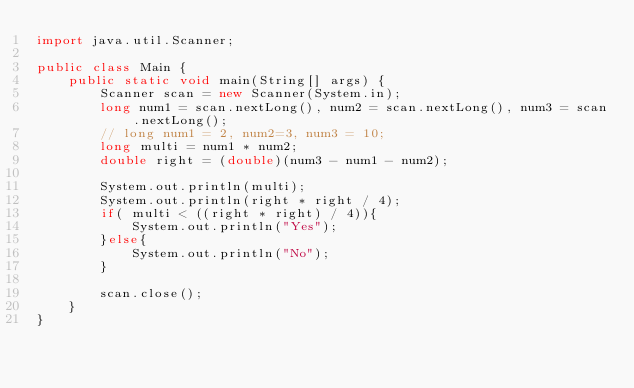Convert code to text. <code><loc_0><loc_0><loc_500><loc_500><_Java_>import java.util.Scanner;
 
public class Main {
    public static void main(String[] args) {
        Scanner scan = new Scanner(System.in);
        long num1 = scan.nextLong(), num2 = scan.nextLong(), num3 = scan.nextLong();
        // long num1 = 2, num2=3, num3 = 10;
        long multi = num1 * num2;
        double right = (double)(num3 - num1 - num2);

        System.out.println(multi);
        System.out.println(right * right / 4);
        if( multi < ((right * right) / 4)){
            System.out.println("Yes");
        }else{
            System.out.println("No");
        }

        scan.close();
    }
}</code> 